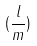Convert formula to latex. <formula><loc_0><loc_0><loc_500><loc_500>( \frac { l } { m } )</formula> 